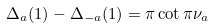<formula> <loc_0><loc_0><loc_500><loc_500>\Delta _ { a } ( 1 ) - \Delta _ { - a } ( 1 ) = \pi \cot \pi \nu _ { a }</formula> 